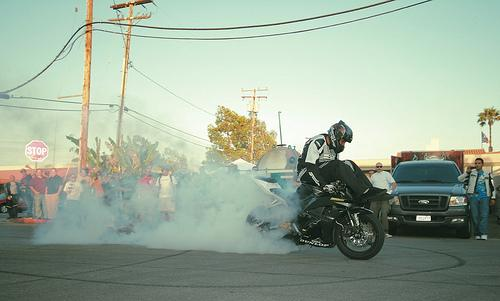What is the primary action taking place in the image? A man is performing a motorcycle trick while emitting a large cloud of smoke. Describe the type of truck present in the image and where people are positioned around it. There is a dark gray or black Ford pickup truck in the image, with men leaning against it. Explain what a person is doing with a camera in the image. A man is taking a photograph of the motorcycle trick in progress. From which object is the smoke coming out of? The smoke is coming from the motorcycle tires. Identify the colors and text on the stop sign in the image. The stop sign is red and white with the word "STOP" on it. Describe the appearance of the main subject of the image. The man performing the motorcycle trick is wearing a black helmet and riding a motorcycle backwards. What is the primary mode of transportation being showcased in the image? A black Suzuki motorcycle. Mention the most unique action a person is doing around the motorcycle trick. A man near the stop sign has raised his fist in the air. List the objects in the image that are visible in the sky. The American flag, a palm tree, green trees in the background, and clear blue sky. Provide a brief description of where the American flag is located in relation to other objects in the image. The American flag is located near a palm tree and a wooden telephone post. 